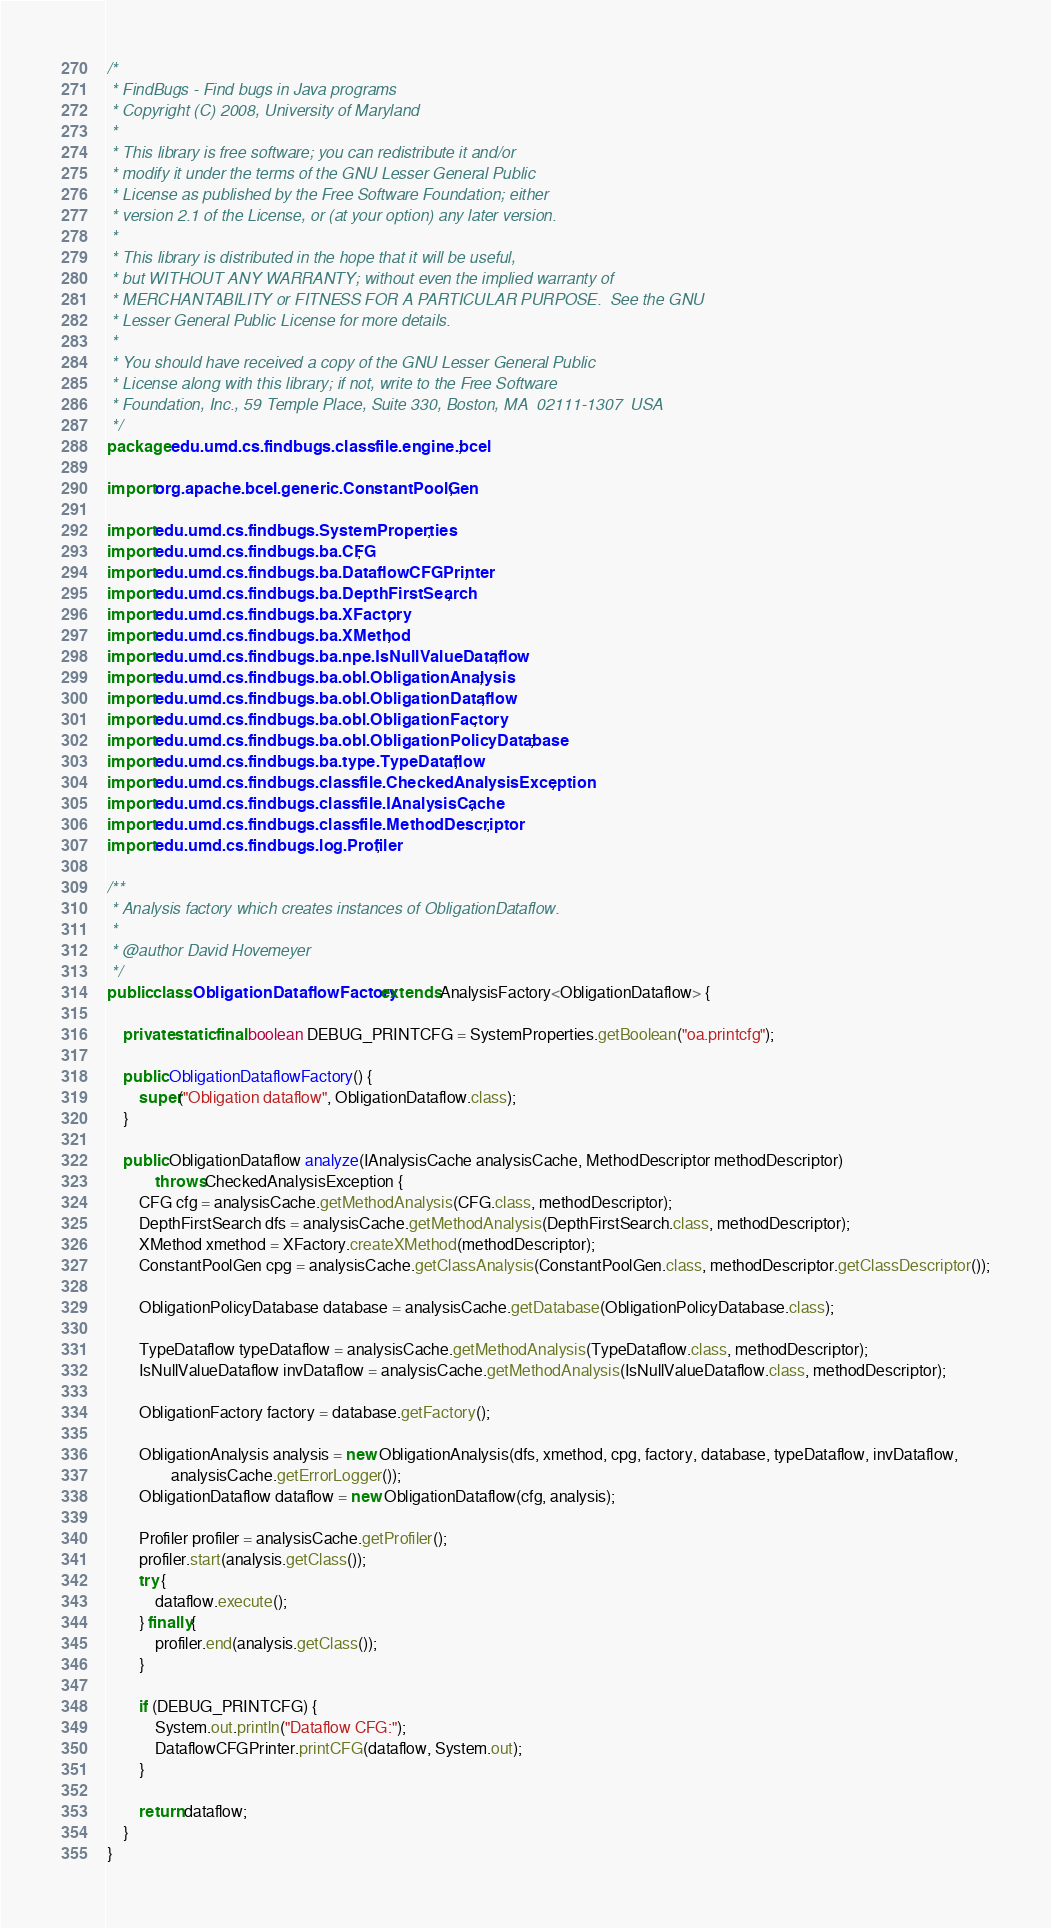Convert code to text. <code><loc_0><loc_0><loc_500><loc_500><_Java_>/*
 * FindBugs - Find bugs in Java programs
 * Copyright (C) 2008, University of Maryland
 *
 * This library is free software; you can redistribute it and/or
 * modify it under the terms of the GNU Lesser General Public
 * License as published by the Free Software Foundation; either
 * version 2.1 of the License, or (at your option) any later version.
 *
 * This library is distributed in the hope that it will be useful,
 * but WITHOUT ANY WARRANTY; without even the implied warranty of
 * MERCHANTABILITY or FITNESS FOR A PARTICULAR PURPOSE.  See the GNU
 * Lesser General Public License for more details.
 *
 * You should have received a copy of the GNU Lesser General Public
 * License along with this library; if not, write to the Free Software
 * Foundation, Inc., 59 Temple Place, Suite 330, Boston, MA  02111-1307  USA
 */
package edu.umd.cs.findbugs.classfile.engine.bcel;

import org.apache.bcel.generic.ConstantPoolGen;

import edu.umd.cs.findbugs.SystemProperties;
import edu.umd.cs.findbugs.ba.CFG;
import edu.umd.cs.findbugs.ba.DataflowCFGPrinter;
import edu.umd.cs.findbugs.ba.DepthFirstSearch;
import edu.umd.cs.findbugs.ba.XFactory;
import edu.umd.cs.findbugs.ba.XMethod;
import edu.umd.cs.findbugs.ba.npe.IsNullValueDataflow;
import edu.umd.cs.findbugs.ba.obl.ObligationAnalysis;
import edu.umd.cs.findbugs.ba.obl.ObligationDataflow;
import edu.umd.cs.findbugs.ba.obl.ObligationFactory;
import edu.umd.cs.findbugs.ba.obl.ObligationPolicyDatabase;
import edu.umd.cs.findbugs.ba.type.TypeDataflow;
import edu.umd.cs.findbugs.classfile.CheckedAnalysisException;
import edu.umd.cs.findbugs.classfile.IAnalysisCache;
import edu.umd.cs.findbugs.classfile.MethodDescriptor;
import edu.umd.cs.findbugs.log.Profiler;

/**
 * Analysis factory which creates instances of ObligationDataflow.
 * 
 * @author David Hovemeyer
 */
public class ObligationDataflowFactory extends AnalysisFactory<ObligationDataflow> {

    private static final boolean DEBUG_PRINTCFG = SystemProperties.getBoolean("oa.printcfg");

    public ObligationDataflowFactory() {
        super("Obligation dataflow", ObligationDataflow.class);
    }

    public ObligationDataflow analyze(IAnalysisCache analysisCache, MethodDescriptor methodDescriptor)
            throws CheckedAnalysisException {
        CFG cfg = analysisCache.getMethodAnalysis(CFG.class, methodDescriptor);
        DepthFirstSearch dfs = analysisCache.getMethodAnalysis(DepthFirstSearch.class, methodDescriptor);
        XMethod xmethod = XFactory.createXMethod(methodDescriptor);
        ConstantPoolGen cpg = analysisCache.getClassAnalysis(ConstantPoolGen.class, methodDescriptor.getClassDescriptor());

        ObligationPolicyDatabase database = analysisCache.getDatabase(ObligationPolicyDatabase.class);

        TypeDataflow typeDataflow = analysisCache.getMethodAnalysis(TypeDataflow.class, methodDescriptor);
        IsNullValueDataflow invDataflow = analysisCache.getMethodAnalysis(IsNullValueDataflow.class, methodDescriptor);

        ObligationFactory factory = database.getFactory();

        ObligationAnalysis analysis = new ObligationAnalysis(dfs, xmethod, cpg, factory, database, typeDataflow, invDataflow,
                analysisCache.getErrorLogger());
        ObligationDataflow dataflow = new ObligationDataflow(cfg, analysis);

        Profiler profiler = analysisCache.getProfiler();
        profiler.start(analysis.getClass());
        try {
            dataflow.execute();
        } finally {
            profiler.end(analysis.getClass());
        }

        if (DEBUG_PRINTCFG) {
            System.out.println("Dataflow CFG:");
            DataflowCFGPrinter.printCFG(dataflow, System.out);
        }

        return dataflow;
    }
}
</code> 